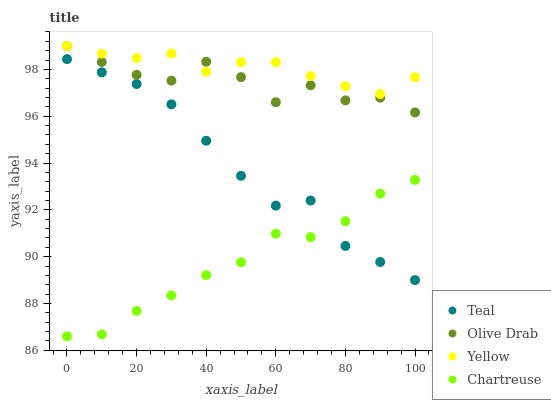Does Chartreuse have the minimum area under the curve?
Answer yes or no. Yes. Does Yellow have the maximum area under the curve?
Answer yes or no. Yes. Does Olive Drab have the minimum area under the curve?
Answer yes or no. No. Does Olive Drab have the maximum area under the curve?
Answer yes or no. No. Is Yellow the smoothest?
Answer yes or no. Yes. Is Olive Drab the roughest?
Answer yes or no. Yes. Is Olive Drab the smoothest?
Answer yes or no. No. Is Yellow the roughest?
Answer yes or no. No. Does Chartreuse have the lowest value?
Answer yes or no. Yes. Does Olive Drab have the lowest value?
Answer yes or no. No. Does Olive Drab have the highest value?
Answer yes or no. Yes. Does Teal have the highest value?
Answer yes or no. No. Is Teal less than Yellow?
Answer yes or no. Yes. Is Olive Drab greater than Teal?
Answer yes or no. Yes. Does Olive Drab intersect Yellow?
Answer yes or no. Yes. Is Olive Drab less than Yellow?
Answer yes or no. No. Is Olive Drab greater than Yellow?
Answer yes or no. No. Does Teal intersect Yellow?
Answer yes or no. No. 